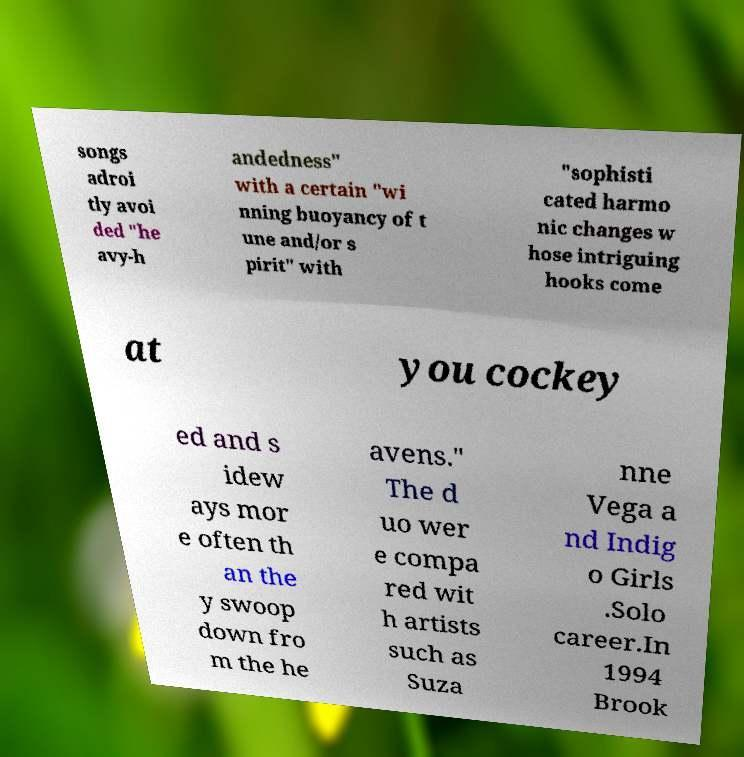What messages or text are displayed in this image? I need them in a readable, typed format. songs adroi tly avoi ded "he avy-h andedness" with a certain "wi nning buoyancy of t une and/or s pirit" with "sophisti cated harmo nic changes w hose intriguing hooks come at you cockey ed and s idew ays mor e often th an the y swoop down fro m the he avens." The d uo wer e compa red wit h artists such as Suza nne Vega a nd Indig o Girls .Solo career.In 1994 Brook 